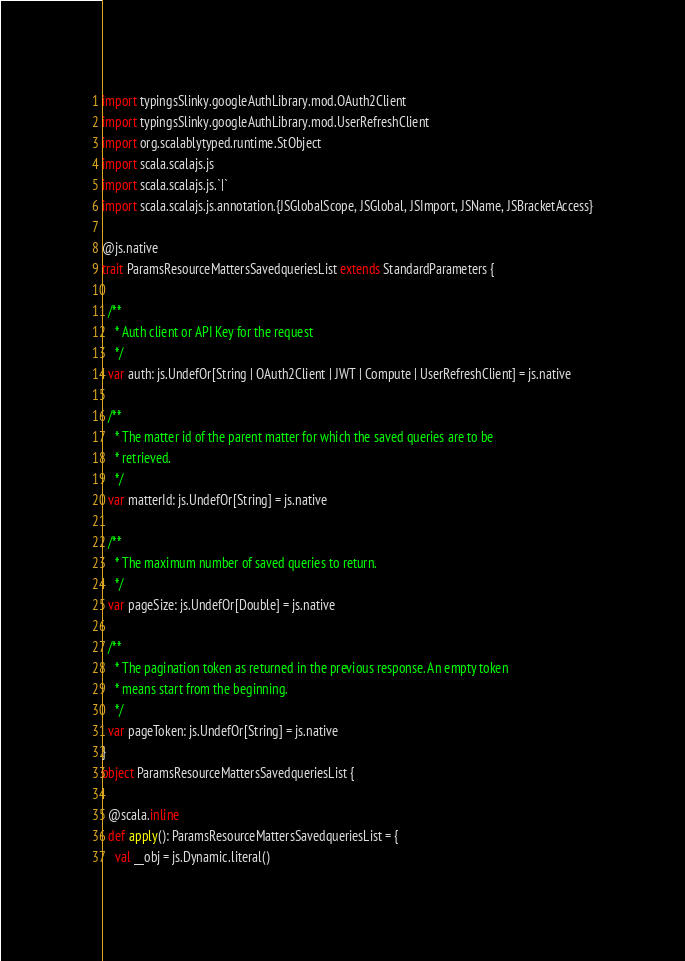<code> <loc_0><loc_0><loc_500><loc_500><_Scala_>import typingsSlinky.googleAuthLibrary.mod.OAuth2Client
import typingsSlinky.googleAuthLibrary.mod.UserRefreshClient
import org.scalablytyped.runtime.StObject
import scala.scalajs.js
import scala.scalajs.js.`|`
import scala.scalajs.js.annotation.{JSGlobalScope, JSGlobal, JSImport, JSName, JSBracketAccess}

@js.native
trait ParamsResourceMattersSavedqueriesList extends StandardParameters {
  
  /**
    * Auth client or API Key for the request
    */
  var auth: js.UndefOr[String | OAuth2Client | JWT | Compute | UserRefreshClient] = js.native
  
  /**
    * The matter id of the parent matter for which the saved queries are to be
    * retrieved.
    */
  var matterId: js.UndefOr[String] = js.native
  
  /**
    * The maximum number of saved queries to return.
    */
  var pageSize: js.UndefOr[Double] = js.native
  
  /**
    * The pagination token as returned in the previous response. An empty token
    * means start from the beginning.
    */
  var pageToken: js.UndefOr[String] = js.native
}
object ParamsResourceMattersSavedqueriesList {
  
  @scala.inline
  def apply(): ParamsResourceMattersSavedqueriesList = {
    val __obj = js.Dynamic.literal()</code> 